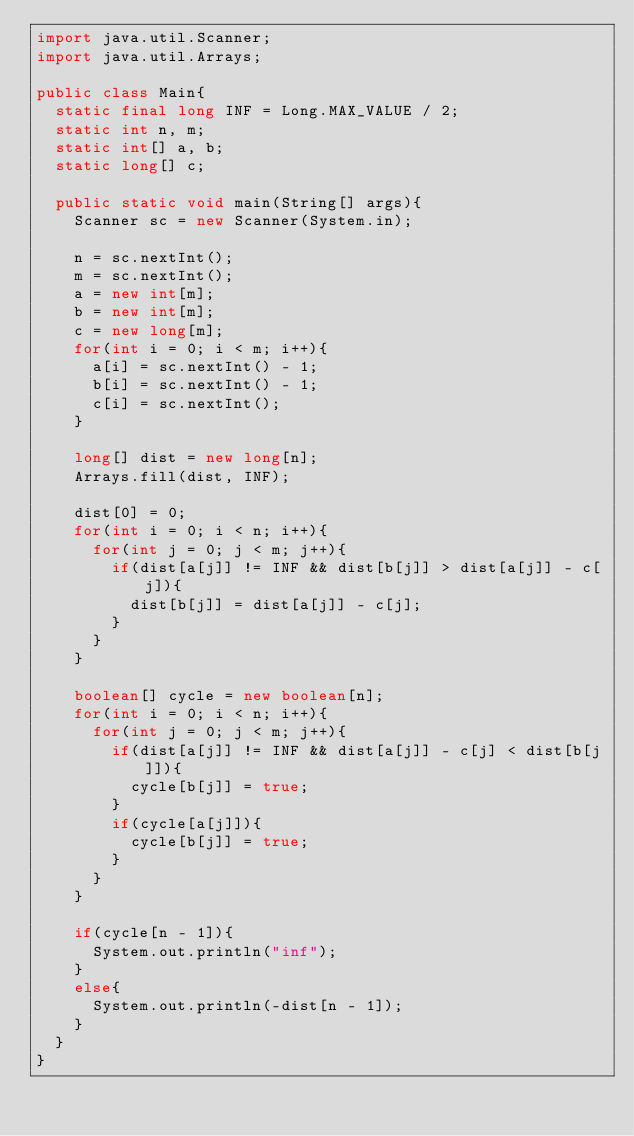<code> <loc_0><loc_0><loc_500><loc_500><_Java_>import java.util.Scanner;
import java.util.Arrays;

public class Main{
  static final long INF = Long.MAX_VALUE / 2;
  static int n, m;
  static int[] a, b;
  static long[] c;

  public static void main(String[] args){
    Scanner sc = new Scanner(System.in);

    n = sc.nextInt();
    m = sc.nextInt();
    a = new int[m];
    b = new int[m];
    c = new long[m];
    for(int i = 0; i < m; i++){
      a[i] = sc.nextInt() - 1;
      b[i] = sc.nextInt() - 1;
      c[i] = sc.nextInt();
    }

    long[] dist = new long[n];
    Arrays.fill(dist, INF);

    dist[0] = 0;
    for(int i = 0; i < n; i++){
      for(int j = 0; j < m; j++){
        if(dist[a[j]] != INF && dist[b[j]] > dist[a[j]] - c[j]){
          dist[b[j]] = dist[a[j]] - c[j];
        }
      }
    }

    boolean[] cycle = new boolean[n];
    for(int i = 0; i < n; i++){
      for(int j = 0; j < m; j++){
        if(dist[a[j]] != INF && dist[a[j]] - c[j] < dist[b[j]]){
          cycle[b[j]] = true;
        }
        if(cycle[a[j]]){
          cycle[b[j]] = true;
        }
      }
    }

    if(cycle[n - 1]){
      System.out.println("inf");
    }
    else{
      System.out.println(-dist[n - 1]);
    }
  }
}
</code> 